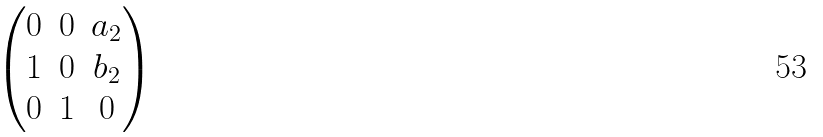Convert formula to latex. <formula><loc_0><loc_0><loc_500><loc_500>\begin{pmatrix} 0 & 0 & a _ { 2 } \\ 1 & 0 & b _ { 2 } \\ 0 & 1 & 0 \end{pmatrix}</formula> 